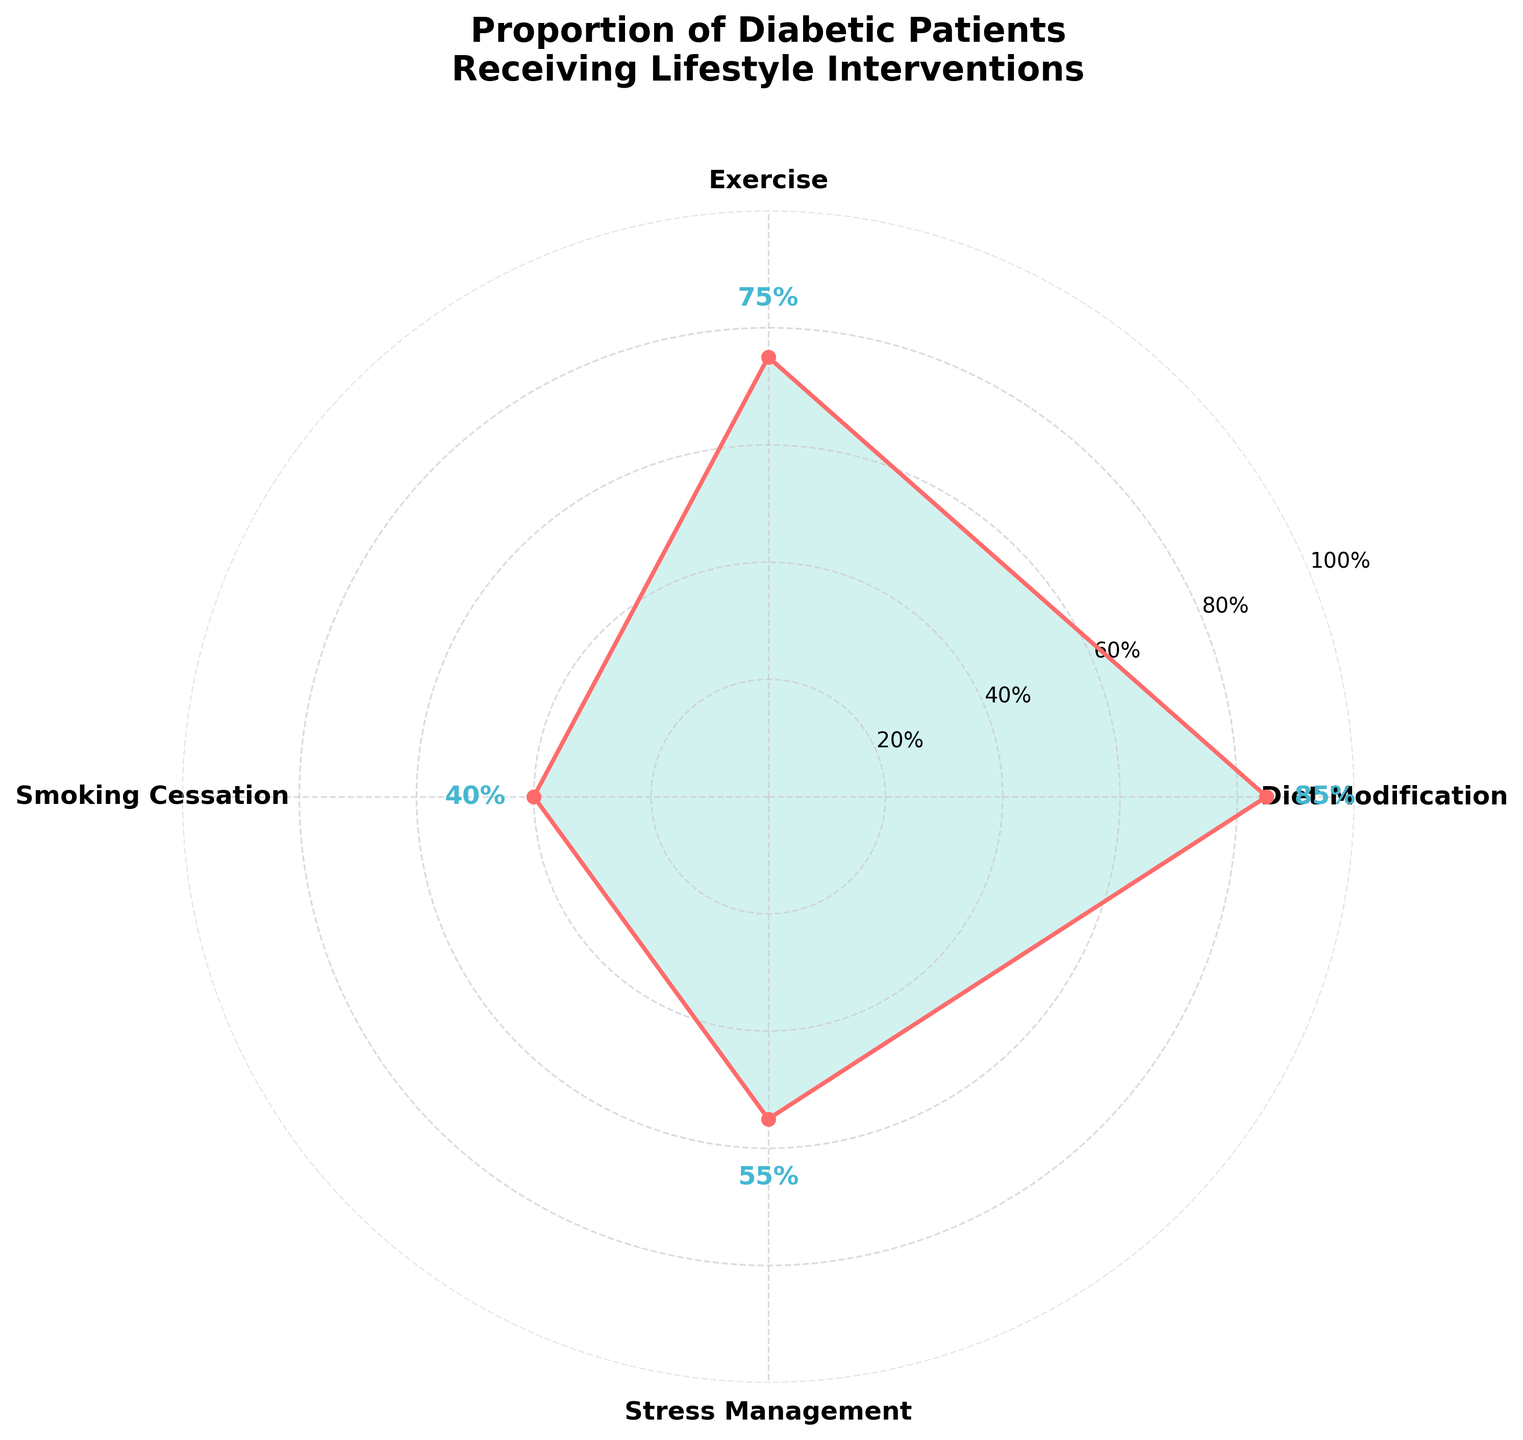What is the title of the chart? The title of the chart is prominently displayed at the top, which reads "Proportion of Diabetic Patients Receiving Lifestyle Interventions." This helps the viewer understand what the data and visualizations represent.
Answer: Proportion of Diabetic Patients Receiving Lifestyle Interventions Which intervention has the highest proportion? By observing the plotted data, the intervention with the highest proportion is the one that reaches closest to the outer circle of the polar plot. In this case, it is "Diet Modification" which reaches 85%.
Answer: Diet Modification How many lifestyle interventions are represented in the chart? To determine the number of interventions, count the distinct categories marked around the circumference of the polar plot. There are four different interventions indicated by the labels around the chart.
Answer: Four What is the proportion of diabetic patients receiving Stress Management? Locate the "Stress Management" label on the polar plot and follow the corresponding line to measure the radial distance from the center. The figure shows this at 55% for Stress Management.
Answer: 55% What is the difference in proportion between Exercise and Smoking Cessation? Identify the proportions for Exercise and Smoking Cessation. Exercise is at 75% and Smoking Cessation is at 40%. Subtract the smaller proportion from the larger to find the difference: 75% - 40%.
Answer: 35% Which interventions have a proportion lower than 60%? Examine the chart for interventions where the proportions are plotted below the 60% radial marker. Both Smoking Cessation (40%) and Stress Management (55%) fall under this category.
Answer: Smoking Cessation and Stress Management If you average the proportions of Diet Modification and Smoking Cessation, what is the result? Find the proportions for Diet Modification and Smoking Cessation, which are 85% and 40% respectively. Sum these values (85 + 40) and then divide by 2 to find the average: (85 + 40) / 2.
Answer: 62.5% Is there an intervention with a proportion exactly at 75%? Refer to the chart for any category with the radial line extending to 75%. The intervention marked at this proportion is Exercise.
Answer: Exercise What's the proportion range of all the interventions presented in the chart? Identify the lowest and highest values from the proportions shown in the chart. The lowest proportion is for Smoking Cessation (40%) and the highest is for Diet Modification (85%), giving a range (85 - 40).
Answer: 40% to 85% Are there any interventions with proportions that are within 5 percentage points of each other? Compare the proportions indicated for each intervention. Stress Management (55%) and Smoking Cessation (40%) have a difference of 15%, and Diet Modification (85%) and Exercise (75%) have a difference of 10%. No interventions fall within 5 percentage points of each other.
Answer: No 